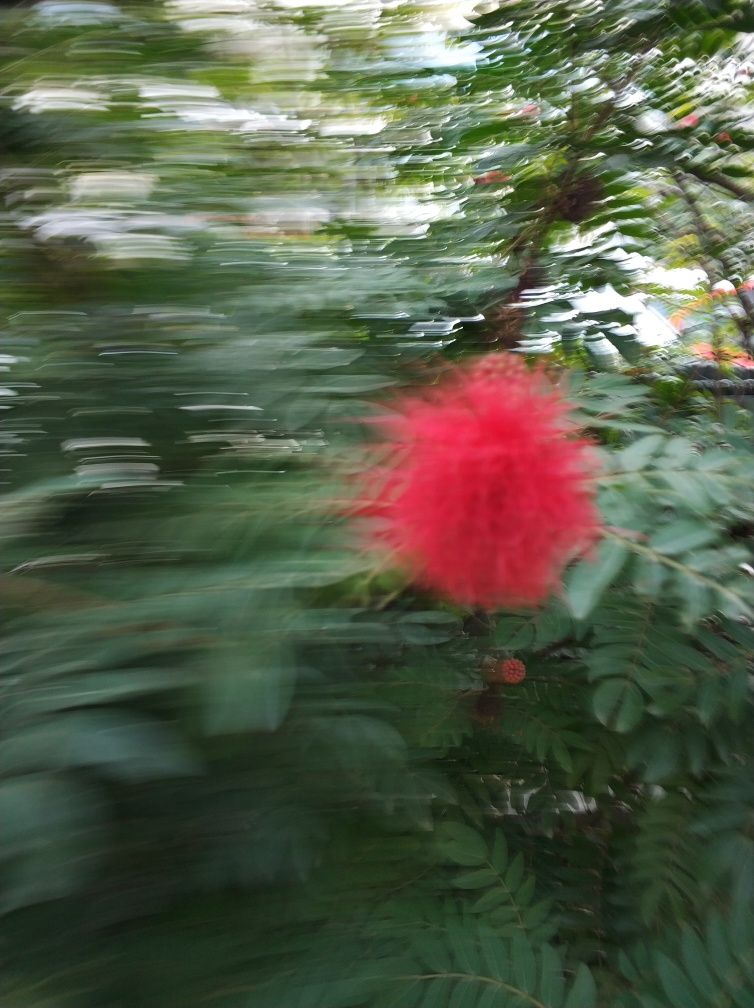Could you describe the main subject of the photo? Certainly, the main subject of the photo seems to be a red, fluffy tropical flower, which stands out with its vivid color and distinctive shape against the green, motion-blurred background of leaves. 